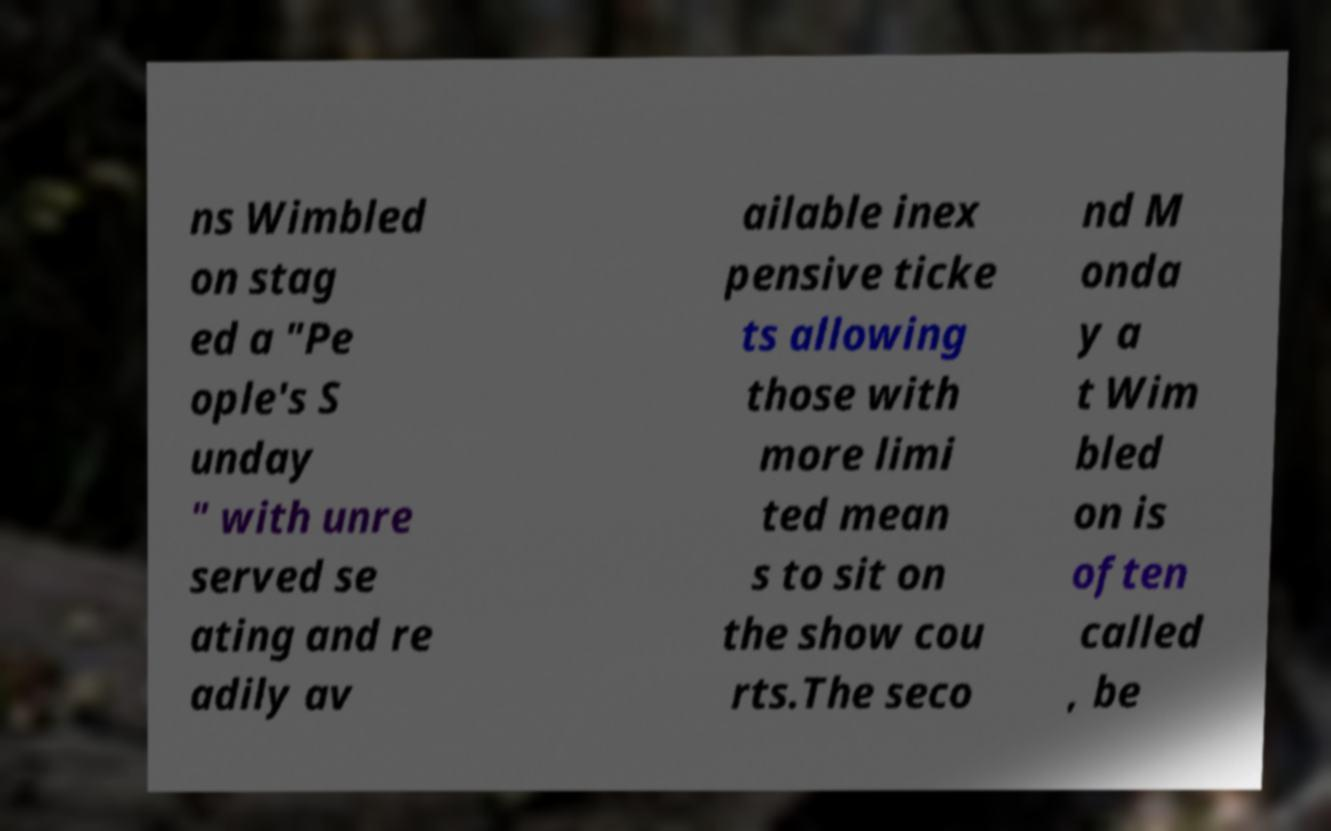Could you assist in decoding the text presented in this image and type it out clearly? ns Wimbled on stag ed a "Pe ople's S unday " with unre served se ating and re adily av ailable inex pensive ticke ts allowing those with more limi ted mean s to sit on the show cou rts.The seco nd M onda y a t Wim bled on is often called , be 